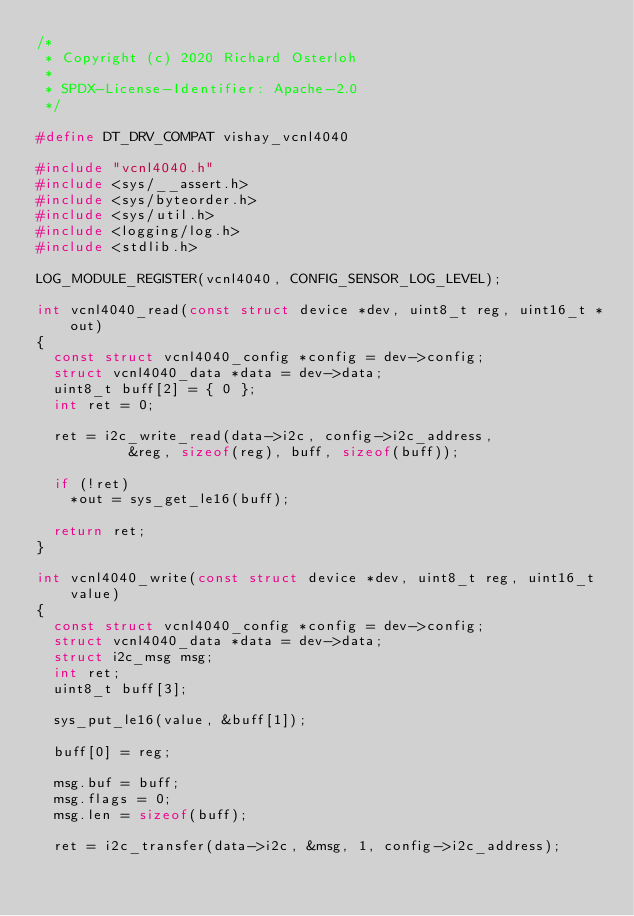Convert code to text. <code><loc_0><loc_0><loc_500><loc_500><_C_>/*
 * Copyright (c) 2020 Richard Osterloh
 *
 * SPDX-License-Identifier: Apache-2.0
 */

#define DT_DRV_COMPAT vishay_vcnl4040

#include "vcnl4040.h"
#include <sys/__assert.h>
#include <sys/byteorder.h>
#include <sys/util.h>
#include <logging/log.h>
#include <stdlib.h>

LOG_MODULE_REGISTER(vcnl4040, CONFIG_SENSOR_LOG_LEVEL);

int vcnl4040_read(const struct device *dev, uint8_t reg, uint16_t *out)
{
	const struct vcnl4040_config *config = dev->config;
	struct vcnl4040_data *data = dev->data;
	uint8_t buff[2] = { 0 };
	int ret = 0;

	ret = i2c_write_read(data->i2c, config->i2c_address,
			     &reg, sizeof(reg), buff, sizeof(buff));

	if (!ret)
		*out = sys_get_le16(buff);

	return ret;
}

int vcnl4040_write(const struct device *dev, uint8_t reg, uint16_t value)
{
	const struct vcnl4040_config *config = dev->config;
	struct vcnl4040_data *data = dev->data;
	struct i2c_msg msg;
	int ret;
	uint8_t buff[3];

	sys_put_le16(value, &buff[1]);

	buff[0] = reg;

	msg.buf = buff;
	msg.flags = 0;
	msg.len = sizeof(buff);

	ret = i2c_transfer(data->i2c, &msg, 1, config->i2c_address);
</code> 